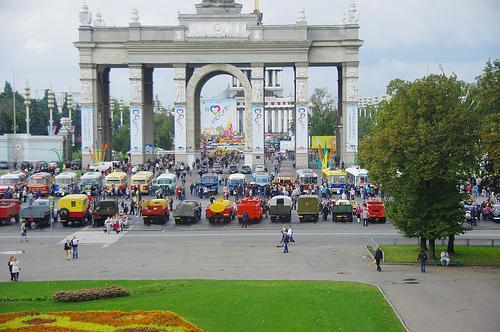How many rows of trucks are there?
Give a very brief answer. 2. 